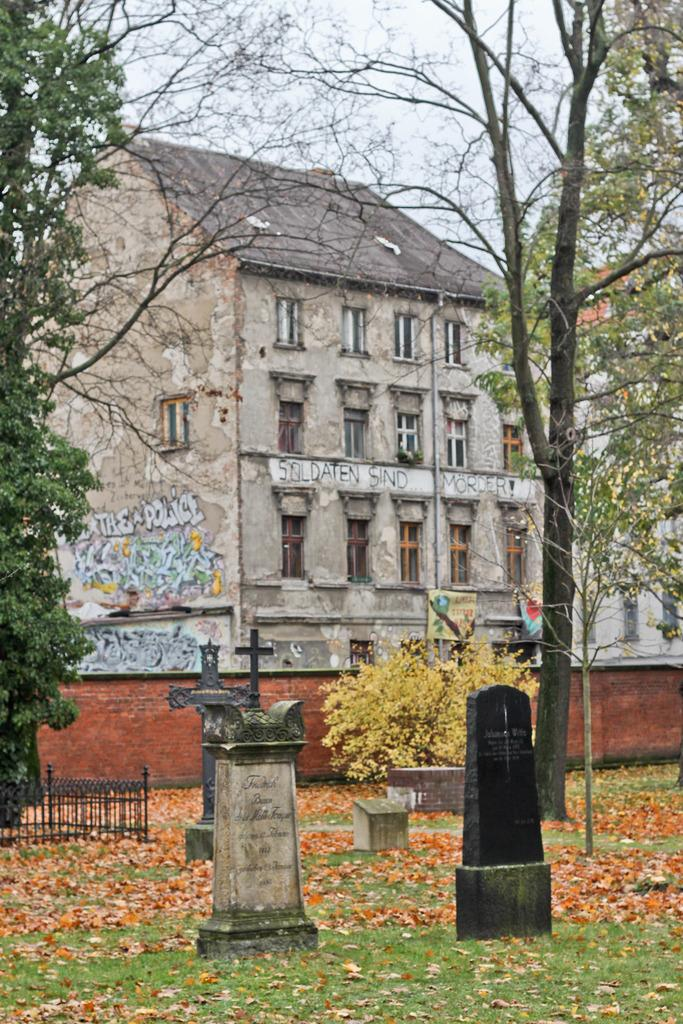What type of structures can be seen in the image? There are buildings in the image. What features can be observed on the buildings? The buildings have windows. What natural elements are present in the image? There are many trees, grass, and dry leaves in the image. What is visible in the sky? The sky is visible in the image. What additional features can be seen in the image? There are memorials, a fence, and a wall in the image. What type of band can be seen playing music in the image? There is no band present in the image. What type of sink is visible in the image? There is no sink present in the image. 